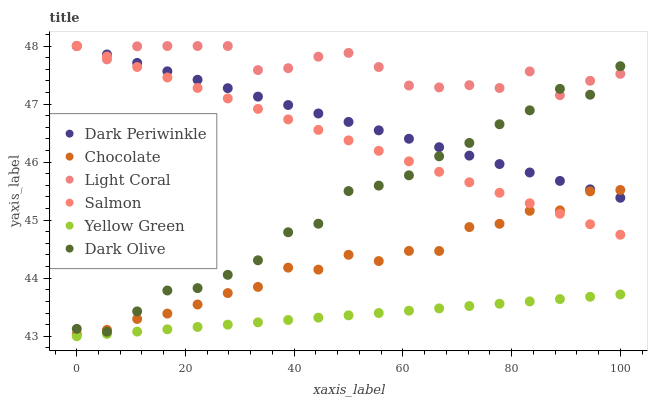Does Yellow Green have the minimum area under the curve?
Answer yes or no. Yes. Does Light Coral have the maximum area under the curve?
Answer yes or no. Yes. Does Dark Olive have the minimum area under the curve?
Answer yes or no. No. Does Dark Olive have the maximum area under the curve?
Answer yes or no. No. Is Yellow Green the smoothest?
Answer yes or no. Yes. Is Light Coral the roughest?
Answer yes or no. Yes. Is Dark Olive the smoothest?
Answer yes or no. No. Is Dark Olive the roughest?
Answer yes or no. No. Does Yellow Green have the lowest value?
Answer yes or no. Yes. Does Dark Olive have the lowest value?
Answer yes or no. No. Does Dark Periwinkle have the highest value?
Answer yes or no. Yes. Does Dark Olive have the highest value?
Answer yes or no. No. Is Yellow Green less than Salmon?
Answer yes or no. Yes. Is Dark Olive greater than Yellow Green?
Answer yes or no. Yes. Does Dark Periwinkle intersect Dark Olive?
Answer yes or no. Yes. Is Dark Periwinkle less than Dark Olive?
Answer yes or no. No. Is Dark Periwinkle greater than Dark Olive?
Answer yes or no. No. Does Yellow Green intersect Salmon?
Answer yes or no. No. 